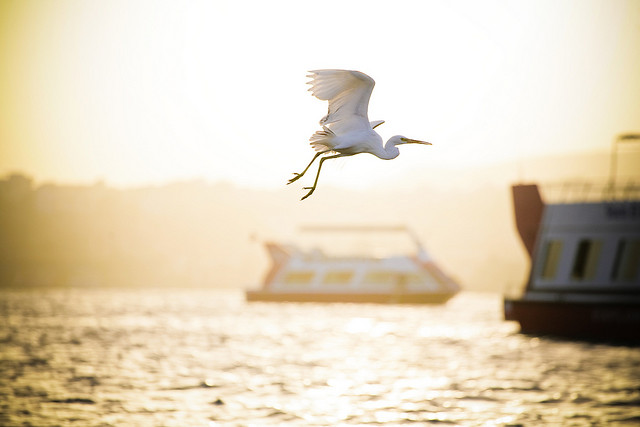Please provide the bounding box coordinate of the region this sentence describes: boat under bird. The bounding box coordinates for 'boat under bird' are [0.38, 0.51, 0.72, 0.64]. 